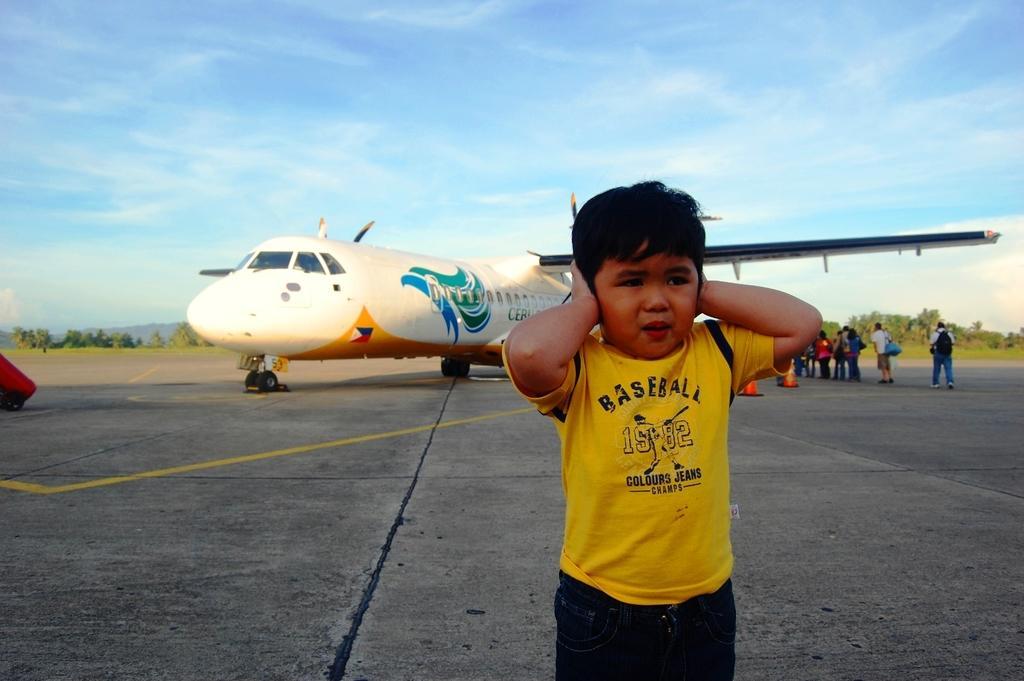In one or two sentences, can you explain what this image depicts? This is an outside view. Here I can see a boy standing on the ground. In the background there is an airplane. On the right side there are few people standing facing towards the airplane. In the background there are many trees. At the top of the image I can see the sky. 